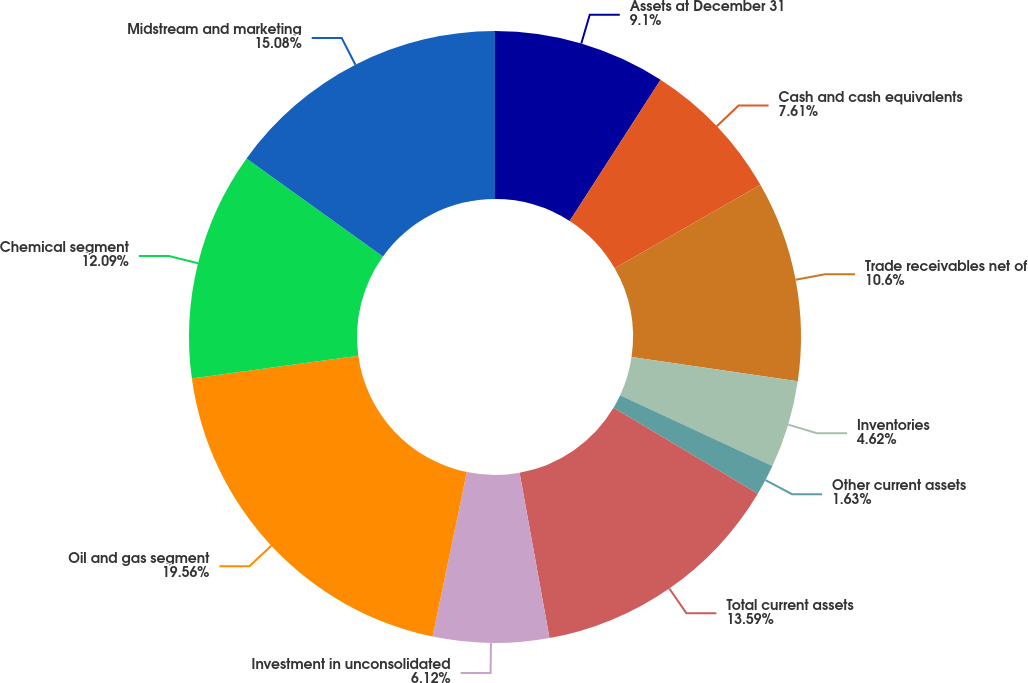Convert chart to OTSL. <chart><loc_0><loc_0><loc_500><loc_500><pie_chart><fcel>Assets at December 31<fcel>Cash and cash equivalents<fcel>Trade receivables net of<fcel>Inventories<fcel>Other current assets<fcel>Total current assets<fcel>Investment in unconsolidated<fcel>Oil and gas segment<fcel>Chemical segment<fcel>Midstream and marketing<nl><fcel>9.1%<fcel>7.61%<fcel>10.6%<fcel>4.62%<fcel>1.63%<fcel>13.59%<fcel>6.12%<fcel>19.56%<fcel>12.09%<fcel>15.08%<nl></chart> 